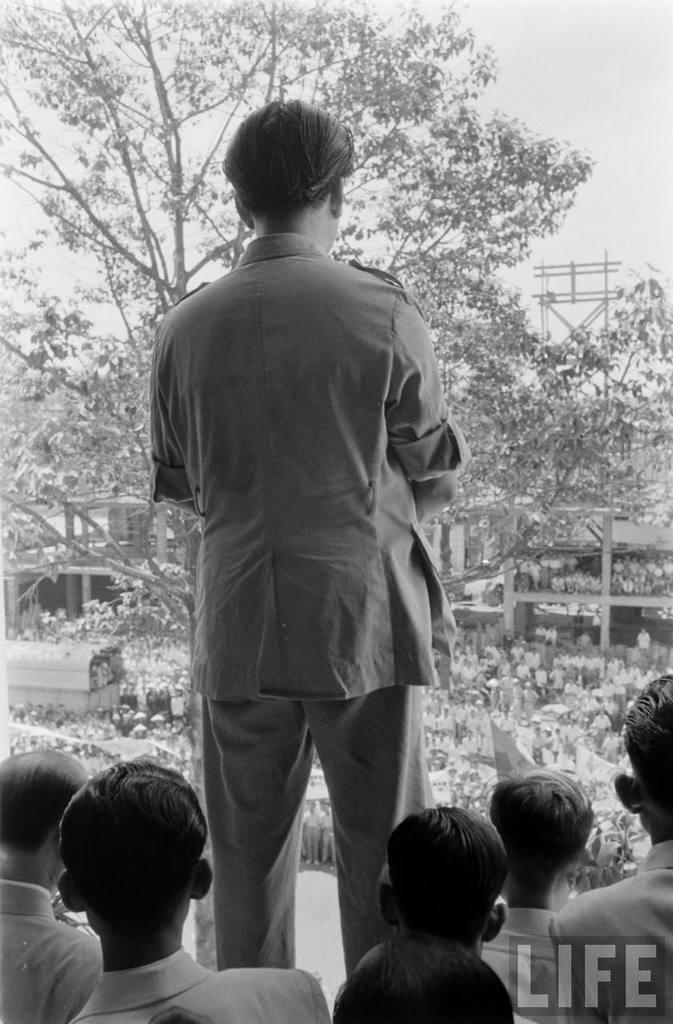Describe this image in one or two sentences. In this picture there is a man who is wearing shirt and trouser. He is standing on the stage. At the bottom we can see the group of persons were standing beside him. In the bottom right corner there is a watermark. In the background we can see many peoples were standing on the road, beside the tree, inside the building and near to the shed. In the top right corner i can see the sky and clouds. 